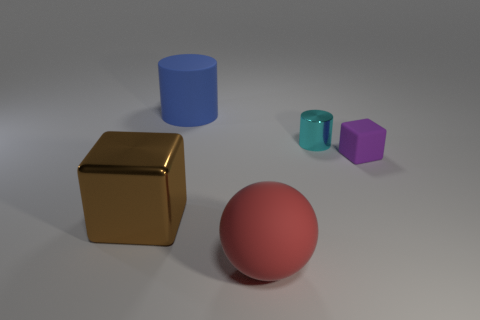Is there anything else that is the same shape as the large red matte object?
Give a very brief answer. No. What number of objects are large yellow metallic blocks or large red matte objects?
Offer a very short reply. 1. There is a cyan thing that is the same shape as the large blue matte thing; what is its size?
Make the answer very short. Small. Are there any other things that have the same size as the brown metal object?
Make the answer very short. Yes. What number of other things are there of the same color as the big matte sphere?
Offer a terse response. 0. How many cubes are red things or purple things?
Ensure brevity in your answer.  1. What is the color of the metal object that is to the left of the shiny object to the right of the big brown object?
Keep it short and to the point. Brown. What is the shape of the brown shiny thing?
Your response must be concise. Cube. There is a metal object left of the sphere; is its size the same as the purple rubber thing?
Make the answer very short. No. Is there a large green cube that has the same material as the small purple cube?
Give a very brief answer. No. 